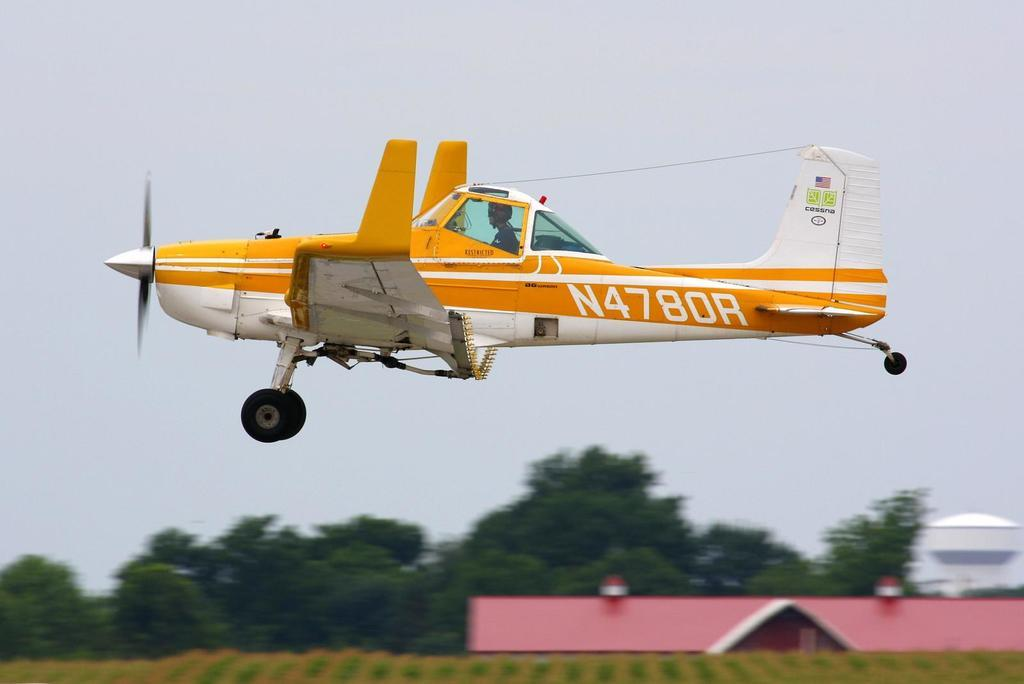Provide a one-sentence caption for the provided image. A yellow plane with the numbers N4780R written upon its side. 